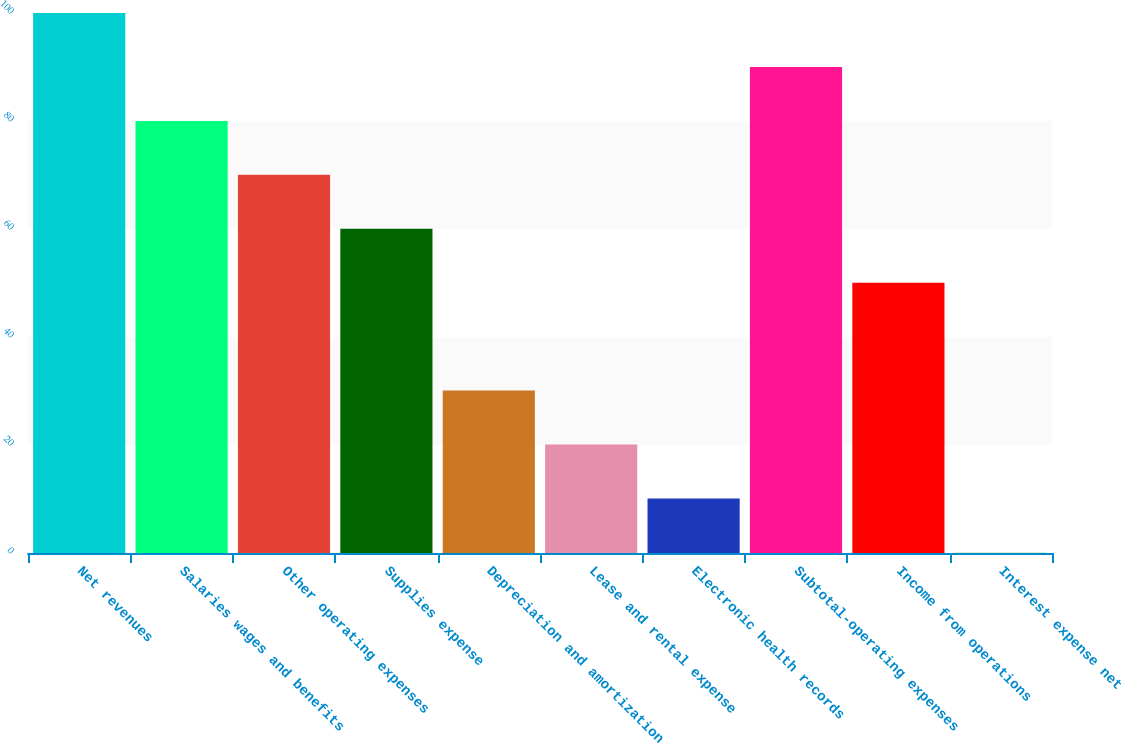<chart> <loc_0><loc_0><loc_500><loc_500><bar_chart><fcel>Net revenues<fcel>Salaries wages and benefits<fcel>Other operating expenses<fcel>Supplies expense<fcel>Depreciation and amortization<fcel>Lease and rental expense<fcel>Electronic health records<fcel>Subtotal-operating expenses<fcel>Income from operations<fcel>Interest expense net<nl><fcel>100<fcel>80.02<fcel>70.03<fcel>60.04<fcel>30.07<fcel>20.08<fcel>10.09<fcel>90.01<fcel>50.05<fcel>0.1<nl></chart> 